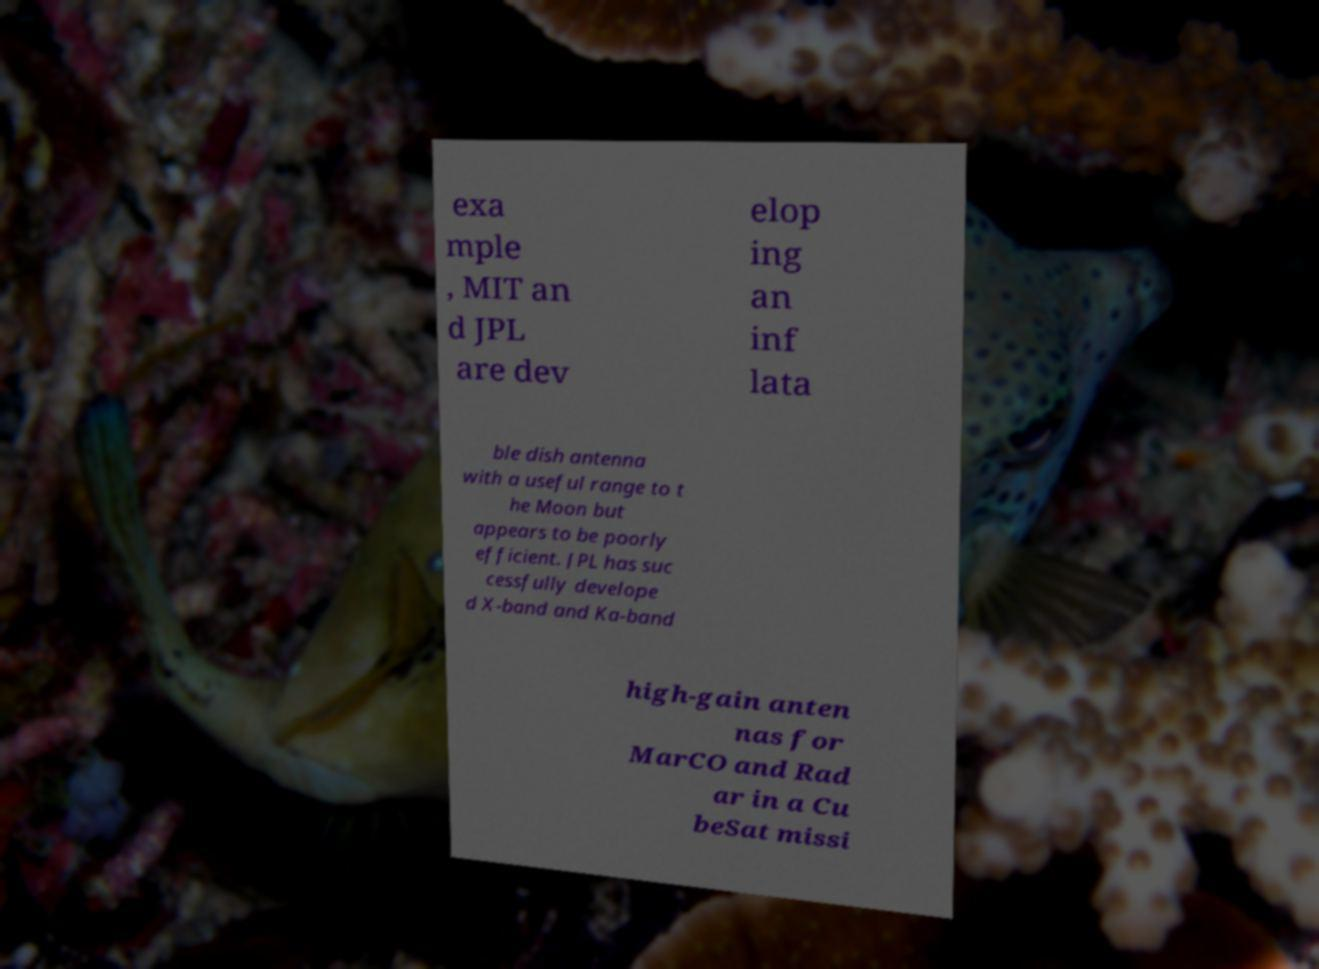For documentation purposes, I need the text within this image transcribed. Could you provide that? exa mple , MIT an d JPL are dev elop ing an inf lata ble dish antenna with a useful range to t he Moon but appears to be poorly efficient. JPL has suc cessfully develope d X-band and Ka-band high-gain anten nas for MarCO and Rad ar in a Cu beSat missi 